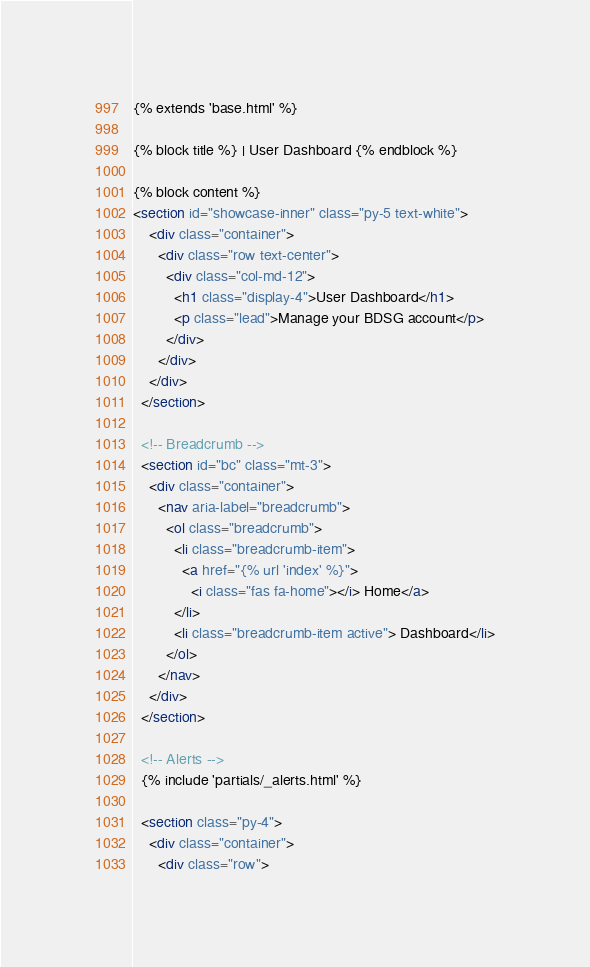<code> <loc_0><loc_0><loc_500><loc_500><_HTML_>{% extends 'base.html' %}

{% block title %} | User Dashboard {% endblock %}

{% block content %}
<section id="showcase-inner" class="py-5 text-white">
    <div class="container">
      <div class="row text-center">
        <div class="col-md-12">
          <h1 class="display-4">User Dashboard</h1>
          <p class="lead">Manage your BDSG account</p>
        </div>
      </div>
    </div>
  </section>

  <!-- Breadcrumb -->
  <section id="bc" class="mt-3">
    <div class="container">
      <nav aria-label="breadcrumb">
        <ol class="breadcrumb">
          <li class="breadcrumb-item">
            <a href="{% url 'index' %}">
              <i class="fas fa-home"></i> Home</a>
          </li>
          <li class="breadcrumb-item active"> Dashboard</li>
        </ol>
      </nav>
    </div>
  </section>

  <!-- Alerts -->
  {% include 'partials/_alerts.html' %}

  <section class="py-4">
    <div class="container">
      <div class="row"></code> 